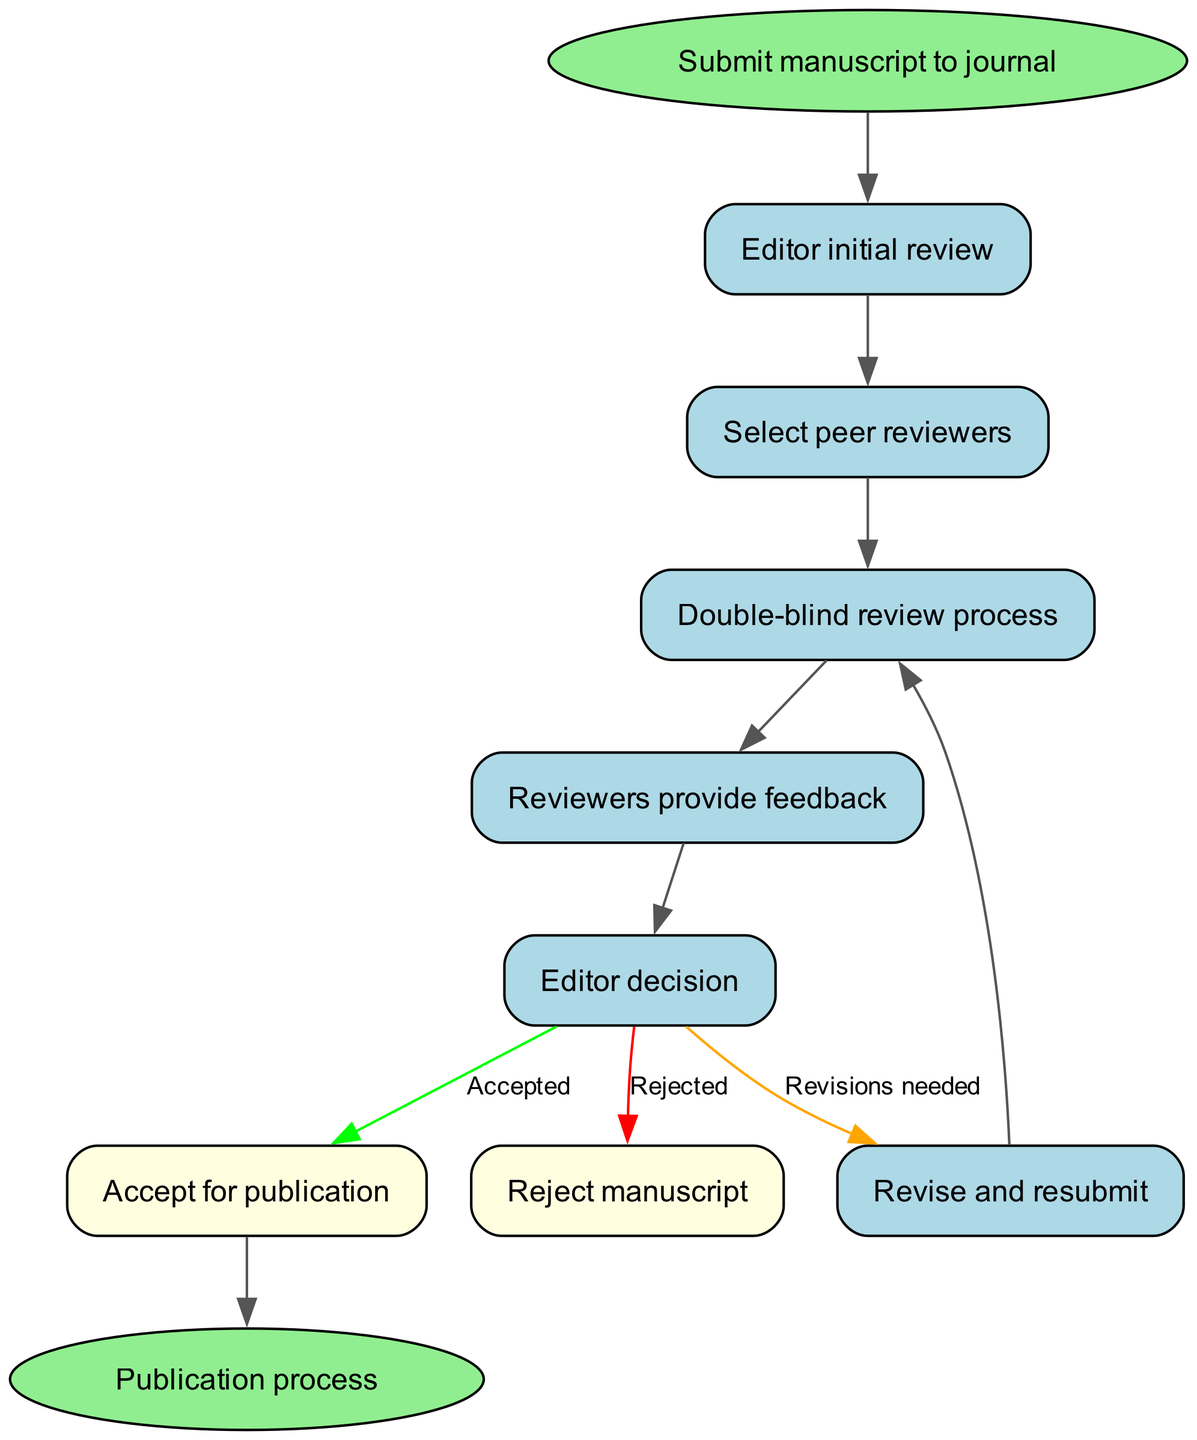What is the first step in the peer review process? The first step is "Submit manuscript to journal," which initiates the process represented in the flow chart.
Answer: Submit manuscript to journal How many nodes are there in the diagram? Upon counting all distinct steps outlined in the flow chart, there are a total of 10 nodes.
Answer: 10 What happens after the editor's initial review? The next step after the "Editor initial review" is "Select peer reviewers," which shows the flow of the process.
Answer: Select peer reviewers Which node follows "feedback"? The node that follows "feedback" is "Editor decision," indicating what comes after reviewers provide their input.
Answer: Editor decision If a manuscript is not accepted, what is the alternative outcome shown in the diagram? The alternative outcome when a manuscript is not accepted is "Reject manuscript," as illustrated in the decision flow following the editor’s evaluation.
Answer: Reject manuscript What is the decision outcome if the editor accepts the manuscript? If the editor accepts the manuscript, the process moves directly to "Publication process," which signifies the completion of the journey.
Answer: Publication process Describe the feedback loop in the peer review process. The feedback loop occurs when the editor decides on "Revise and resubmit," which then leads back to the "Double-blind review process," showing the iterative nature of revisions.
Answer: Revise and resubmit How is the revision decision represented in the flow chart? The revision decision is represented by an edge labeled "Revisions needed" connecting "Editor decision" to "Revise and resubmit," indicating the need for adjustments.
Answer: Revisions needed What color is used for the "Accept for publication" node? The "Accept for publication" node is colored light yellow, distinguishing it from other steps in the diagram.
Answer: Light yellow 